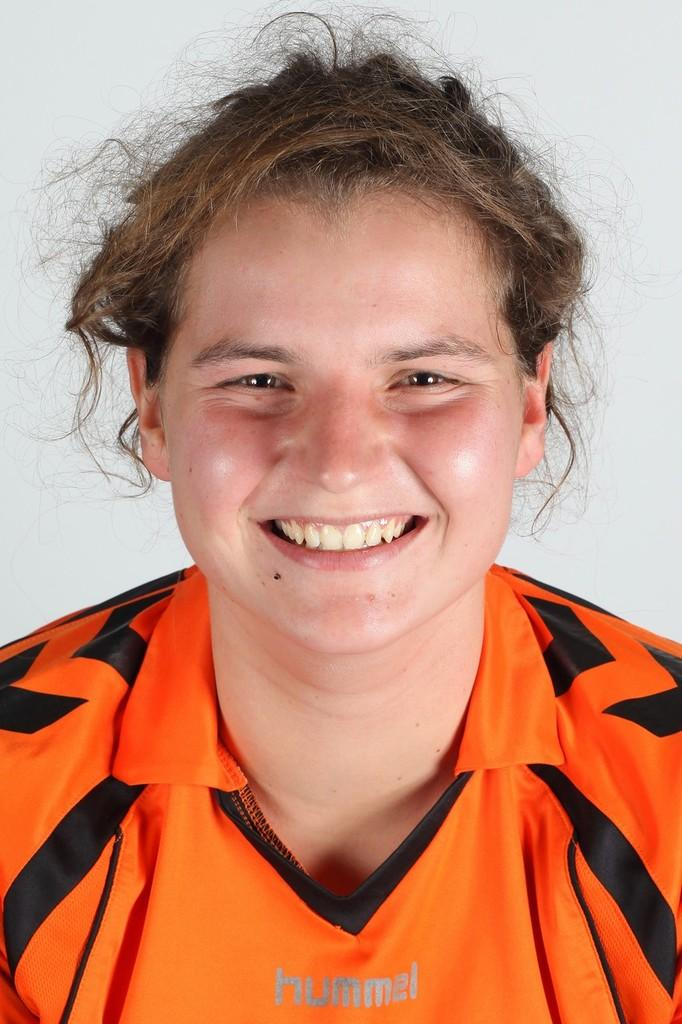Who is the main subject in the image? There is a woman in the image. What color is the background of the image? The background of the image is white. What month is the woman celebrating in the image? There is no indication of a specific month or celebration in the image. Is the woman's mom present in the image? There is no information about the woman's mom in the image. 